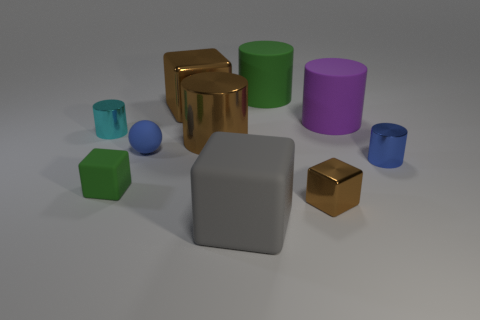What is the size of the metallic object that is the same color as the sphere?
Offer a very short reply. Small. Is the number of small green rubber things that are in front of the small rubber block less than the number of small brown shiny things?
Give a very brief answer. Yes. Are there any small matte objects?
Your answer should be very brief. Yes. What color is the other rubber object that is the same shape as the large green rubber thing?
Ensure brevity in your answer.  Purple. Do the rubber block that is in front of the tiny brown thing and the small metallic cube have the same color?
Offer a terse response. No. Is the size of the green block the same as the blue cylinder?
Your response must be concise. Yes. What is the shape of the tiny blue thing that is the same material as the big gray cube?
Your answer should be compact. Sphere. How many other objects are there of the same shape as the cyan shiny object?
Make the answer very short. 4. What is the shape of the blue thing behind the small cylinder right of the green object that is to the right of the brown metallic cylinder?
Give a very brief answer. Sphere. What number of cylinders are big green matte things or big red matte objects?
Provide a short and direct response. 1. 